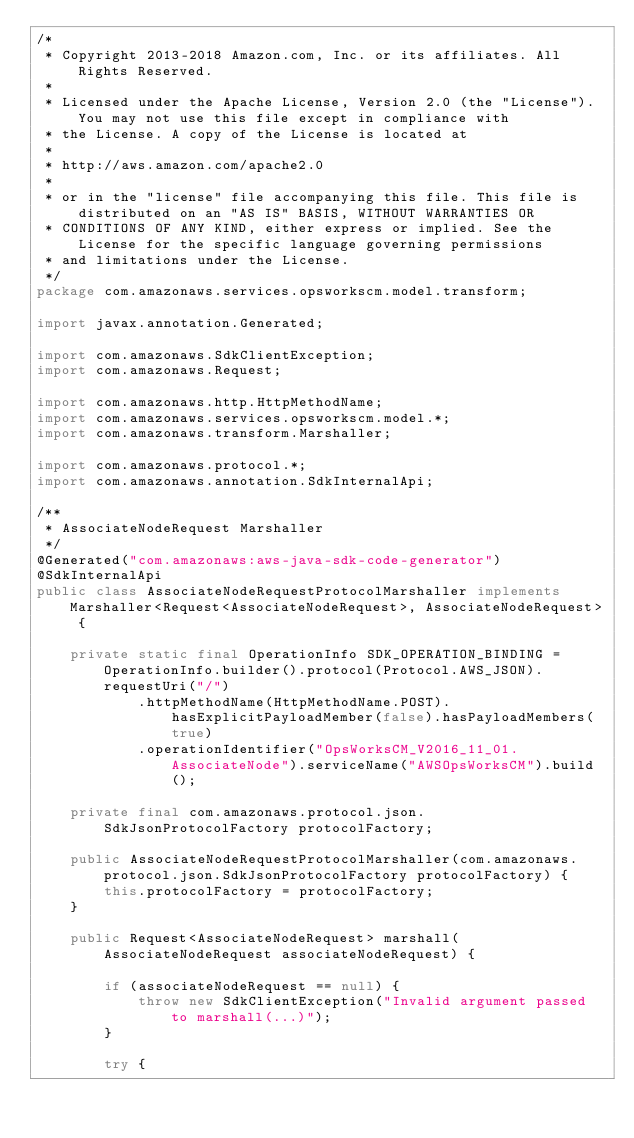Convert code to text. <code><loc_0><loc_0><loc_500><loc_500><_Java_>/*
 * Copyright 2013-2018 Amazon.com, Inc. or its affiliates. All Rights Reserved.
 * 
 * Licensed under the Apache License, Version 2.0 (the "License"). You may not use this file except in compliance with
 * the License. A copy of the License is located at
 * 
 * http://aws.amazon.com/apache2.0
 * 
 * or in the "license" file accompanying this file. This file is distributed on an "AS IS" BASIS, WITHOUT WARRANTIES OR
 * CONDITIONS OF ANY KIND, either express or implied. See the License for the specific language governing permissions
 * and limitations under the License.
 */
package com.amazonaws.services.opsworkscm.model.transform;

import javax.annotation.Generated;

import com.amazonaws.SdkClientException;
import com.amazonaws.Request;

import com.amazonaws.http.HttpMethodName;
import com.amazonaws.services.opsworkscm.model.*;
import com.amazonaws.transform.Marshaller;

import com.amazonaws.protocol.*;
import com.amazonaws.annotation.SdkInternalApi;

/**
 * AssociateNodeRequest Marshaller
 */
@Generated("com.amazonaws:aws-java-sdk-code-generator")
@SdkInternalApi
public class AssociateNodeRequestProtocolMarshaller implements Marshaller<Request<AssociateNodeRequest>, AssociateNodeRequest> {

    private static final OperationInfo SDK_OPERATION_BINDING = OperationInfo.builder().protocol(Protocol.AWS_JSON).requestUri("/")
            .httpMethodName(HttpMethodName.POST).hasExplicitPayloadMember(false).hasPayloadMembers(true)
            .operationIdentifier("OpsWorksCM_V2016_11_01.AssociateNode").serviceName("AWSOpsWorksCM").build();

    private final com.amazonaws.protocol.json.SdkJsonProtocolFactory protocolFactory;

    public AssociateNodeRequestProtocolMarshaller(com.amazonaws.protocol.json.SdkJsonProtocolFactory protocolFactory) {
        this.protocolFactory = protocolFactory;
    }

    public Request<AssociateNodeRequest> marshall(AssociateNodeRequest associateNodeRequest) {

        if (associateNodeRequest == null) {
            throw new SdkClientException("Invalid argument passed to marshall(...)");
        }

        try {</code> 